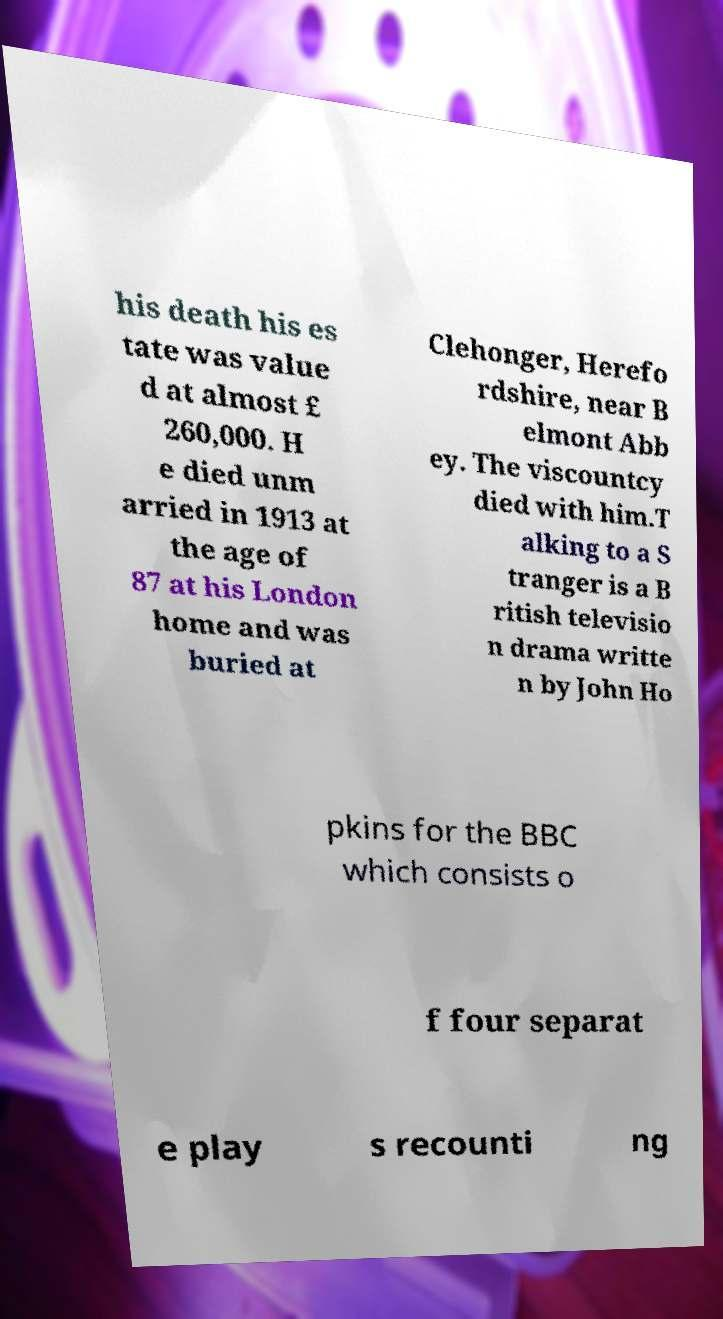I need the written content from this picture converted into text. Can you do that? his death his es tate was value d at almost £ 260,000. H e died unm arried in 1913 at the age of 87 at his London home and was buried at Clehonger, Herefo rdshire, near B elmont Abb ey. The viscountcy died with him.T alking to a S tranger is a B ritish televisio n drama writte n by John Ho pkins for the BBC which consists o f four separat e play s recounti ng 